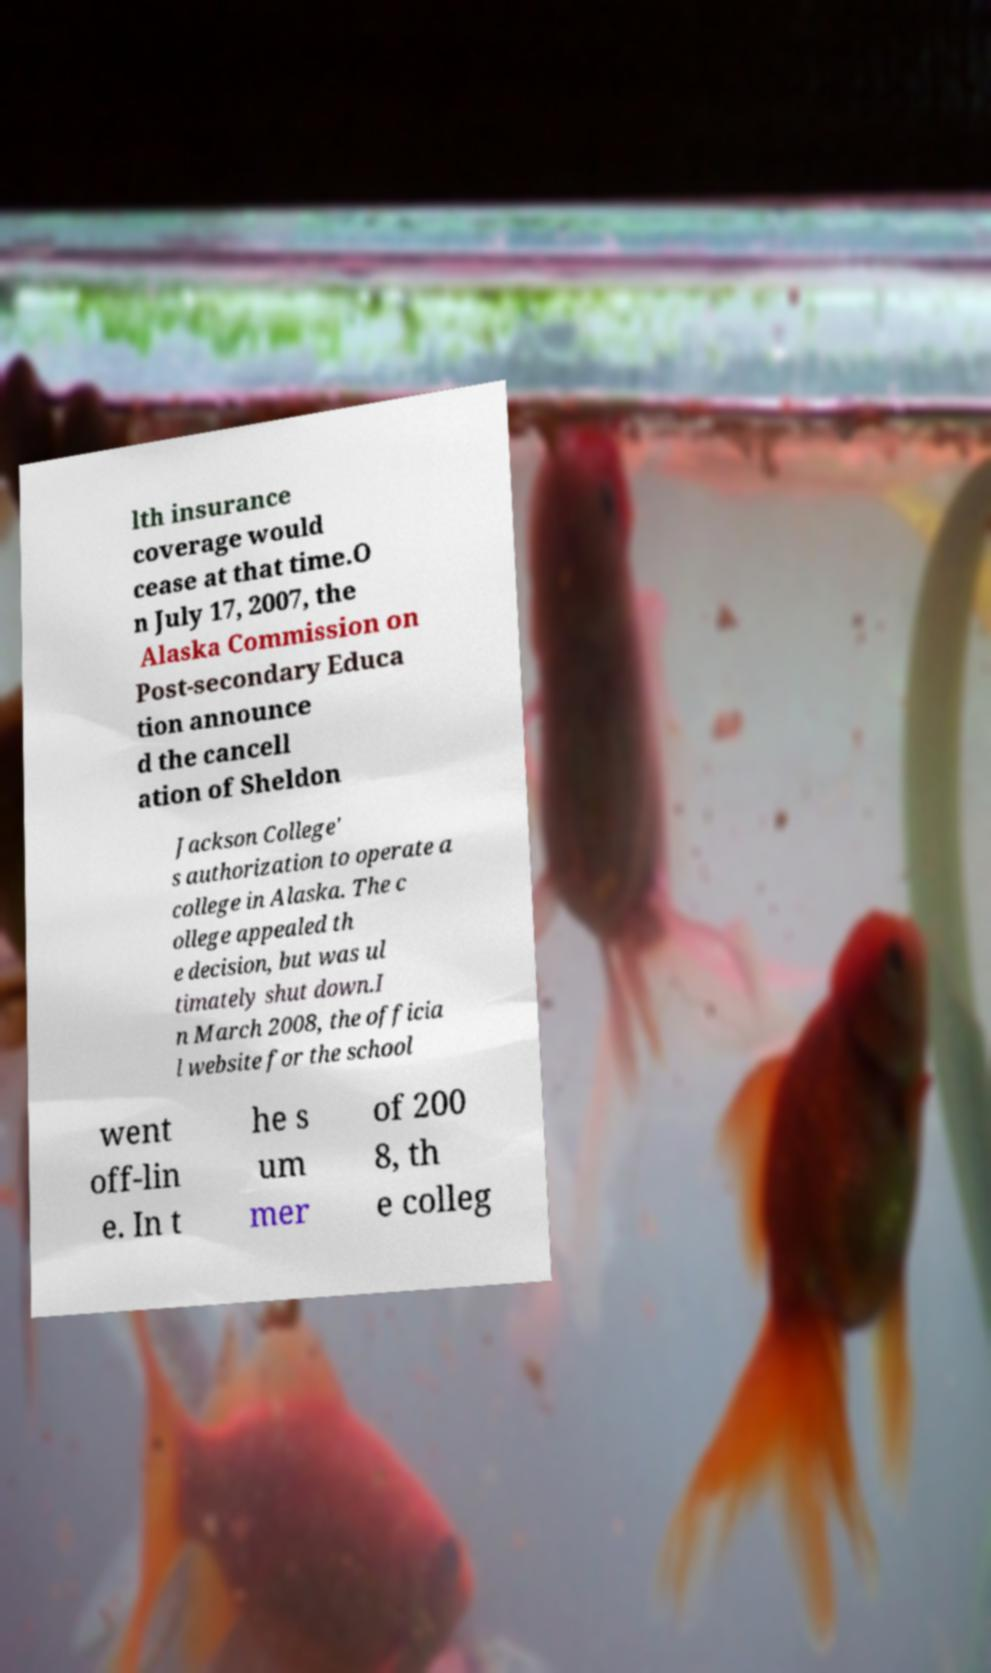Please identify and transcribe the text found in this image. lth insurance coverage would cease at that time.O n July 17, 2007, the Alaska Commission on Post-secondary Educa tion announce d the cancell ation of Sheldon Jackson College' s authorization to operate a college in Alaska. The c ollege appealed th e decision, but was ul timately shut down.I n March 2008, the officia l website for the school went off-lin e. In t he s um mer of 200 8, th e colleg 